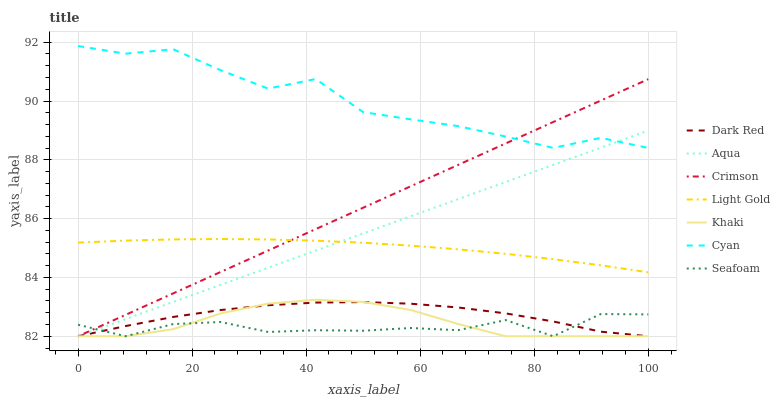Does Seafoam have the minimum area under the curve?
Answer yes or no. Yes. Does Cyan have the maximum area under the curve?
Answer yes or no. Yes. Does Dark Red have the minimum area under the curve?
Answer yes or no. No. Does Dark Red have the maximum area under the curve?
Answer yes or no. No. Is Aqua the smoothest?
Answer yes or no. Yes. Is Cyan the roughest?
Answer yes or no. Yes. Is Dark Red the smoothest?
Answer yes or no. No. Is Dark Red the roughest?
Answer yes or no. No. Does Khaki have the lowest value?
Answer yes or no. Yes. Does Cyan have the lowest value?
Answer yes or no. No. Does Cyan have the highest value?
Answer yes or no. Yes. Does Dark Red have the highest value?
Answer yes or no. No. Is Light Gold less than Cyan?
Answer yes or no. Yes. Is Cyan greater than Light Gold?
Answer yes or no. Yes. Does Khaki intersect Dark Red?
Answer yes or no. Yes. Is Khaki less than Dark Red?
Answer yes or no. No. Is Khaki greater than Dark Red?
Answer yes or no. No. Does Light Gold intersect Cyan?
Answer yes or no. No. 